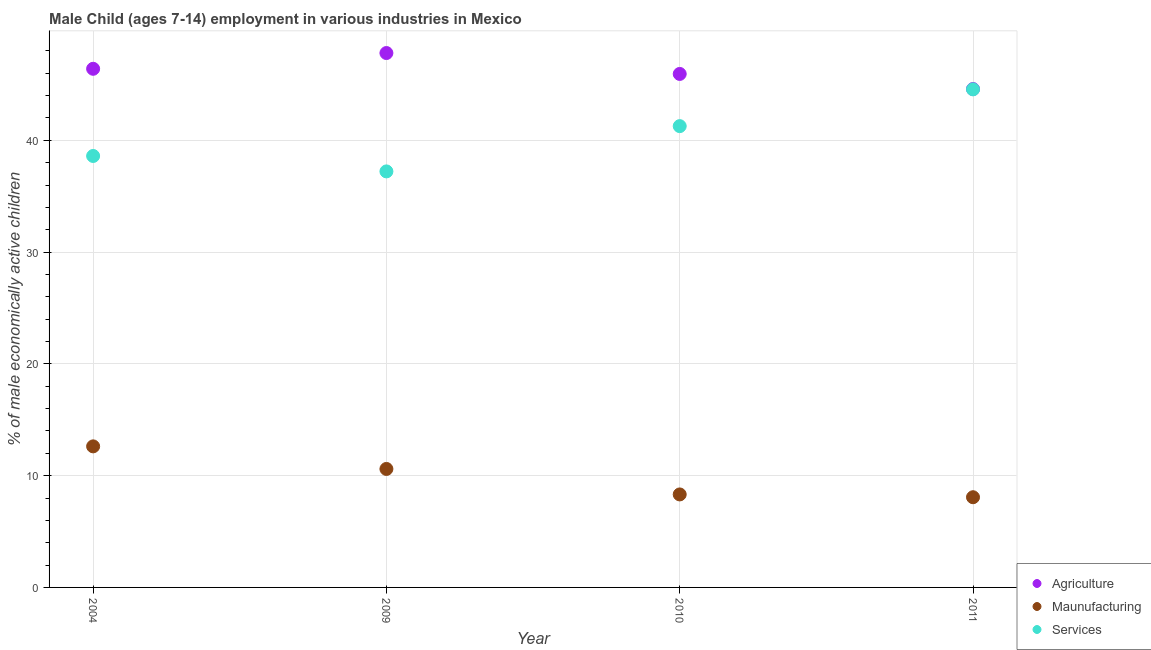How many different coloured dotlines are there?
Give a very brief answer. 3. Is the number of dotlines equal to the number of legend labels?
Ensure brevity in your answer.  Yes. What is the percentage of economically active children in manufacturing in 2009?
Provide a short and direct response. 10.6. Across all years, what is the maximum percentage of economically active children in agriculture?
Offer a very short reply. 47.81. Across all years, what is the minimum percentage of economically active children in manufacturing?
Your answer should be compact. 8.07. In which year was the percentage of economically active children in agriculture maximum?
Offer a terse response. 2009. In which year was the percentage of economically active children in services minimum?
Your answer should be very brief. 2009. What is the total percentage of economically active children in services in the graph?
Provide a succinct answer. 161.65. What is the difference between the percentage of economically active children in services in 2009 and that in 2011?
Provide a short and direct response. -7.34. What is the difference between the percentage of economically active children in services in 2010 and the percentage of economically active children in agriculture in 2004?
Offer a very short reply. -5.13. What is the average percentage of economically active children in services per year?
Give a very brief answer. 40.41. In the year 2009, what is the difference between the percentage of economically active children in services and percentage of economically active children in manufacturing?
Give a very brief answer. 26.62. In how many years, is the percentage of economically active children in manufacturing greater than 34 %?
Provide a short and direct response. 0. What is the ratio of the percentage of economically active children in agriculture in 2010 to that in 2011?
Ensure brevity in your answer.  1.03. Is the percentage of economically active children in agriculture in 2004 less than that in 2010?
Your response must be concise. No. Is the difference between the percentage of economically active children in manufacturing in 2004 and 2009 greater than the difference between the percentage of economically active children in services in 2004 and 2009?
Your response must be concise. Yes. What is the difference between the highest and the second highest percentage of economically active children in manufacturing?
Keep it short and to the point. 2.02. What is the difference between the highest and the lowest percentage of economically active children in manufacturing?
Make the answer very short. 4.55. In how many years, is the percentage of economically active children in services greater than the average percentage of economically active children in services taken over all years?
Ensure brevity in your answer.  2. Is it the case that in every year, the sum of the percentage of economically active children in agriculture and percentage of economically active children in manufacturing is greater than the percentage of economically active children in services?
Keep it short and to the point. Yes. Does the percentage of economically active children in services monotonically increase over the years?
Provide a short and direct response. No. Is the percentage of economically active children in agriculture strictly greater than the percentage of economically active children in manufacturing over the years?
Provide a short and direct response. Yes. Is the percentage of economically active children in services strictly less than the percentage of economically active children in manufacturing over the years?
Ensure brevity in your answer.  No. How many years are there in the graph?
Ensure brevity in your answer.  4. Are the values on the major ticks of Y-axis written in scientific E-notation?
Offer a very short reply. No. Does the graph contain grids?
Provide a short and direct response. Yes. What is the title of the graph?
Keep it short and to the point. Male Child (ages 7-14) employment in various industries in Mexico. Does "Capital account" appear as one of the legend labels in the graph?
Offer a terse response. No. What is the label or title of the Y-axis?
Your answer should be compact. % of male economically active children. What is the % of male economically active children in Agriculture in 2004?
Your response must be concise. 46.4. What is the % of male economically active children in Maunufacturing in 2004?
Keep it short and to the point. 12.62. What is the % of male economically active children in Services in 2004?
Provide a succinct answer. 38.6. What is the % of male economically active children of Agriculture in 2009?
Provide a succinct answer. 47.81. What is the % of male economically active children in Services in 2009?
Provide a short and direct response. 37.22. What is the % of male economically active children of Agriculture in 2010?
Keep it short and to the point. 45.94. What is the % of male economically active children of Maunufacturing in 2010?
Your answer should be compact. 8.32. What is the % of male economically active children of Services in 2010?
Ensure brevity in your answer.  41.27. What is the % of male economically active children of Agriculture in 2011?
Keep it short and to the point. 44.59. What is the % of male economically active children in Maunufacturing in 2011?
Offer a very short reply. 8.07. What is the % of male economically active children in Services in 2011?
Ensure brevity in your answer.  44.56. Across all years, what is the maximum % of male economically active children of Agriculture?
Your response must be concise. 47.81. Across all years, what is the maximum % of male economically active children in Maunufacturing?
Offer a terse response. 12.62. Across all years, what is the maximum % of male economically active children in Services?
Offer a terse response. 44.56. Across all years, what is the minimum % of male economically active children of Agriculture?
Provide a succinct answer. 44.59. Across all years, what is the minimum % of male economically active children in Maunufacturing?
Make the answer very short. 8.07. Across all years, what is the minimum % of male economically active children in Services?
Provide a short and direct response. 37.22. What is the total % of male economically active children in Agriculture in the graph?
Give a very brief answer. 184.74. What is the total % of male economically active children of Maunufacturing in the graph?
Provide a short and direct response. 39.61. What is the total % of male economically active children in Services in the graph?
Your response must be concise. 161.65. What is the difference between the % of male economically active children of Agriculture in 2004 and that in 2009?
Your answer should be compact. -1.41. What is the difference between the % of male economically active children of Maunufacturing in 2004 and that in 2009?
Offer a very short reply. 2.02. What is the difference between the % of male economically active children in Services in 2004 and that in 2009?
Give a very brief answer. 1.38. What is the difference between the % of male economically active children in Agriculture in 2004 and that in 2010?
Your answer should be compact. 0.46. What is the difference between the % of male economically active children of Maunufacturing in 2004 and that in 2010?
Keep it short and to the point. 4.3. What is the difference between the % of male economically active children in Services in 2004 and that in 2010?
Offer a very short reply. -2.67. What is the difference between the % of male economically active children in Agriculture in 2004 and that in 2011?
Keep it short and to the point. 1.81. What is the difference between the % of male economically active children of Maunufacturing in 2004 and that in 2011?
Make the answer very short. 4.55. What is the difference between the % of male economically active children in Services in 2004 and that in 2011?
Provide a short and direct response. -5.96. What is the difference between the % of male economically active children of Agriculture in 2009 and that in 2010?
Offer a very short reply. 1.87. What is the difference between the % of male economically active children in Maunufacturing in 2009 and that in 2010?
Your answer should be very brief. 2.28. What is the difference between the % of male economically active children in Services in 2009 and that in 2010?
Keep it short and to the point. -4.05. What is the difference between the % of male economically active children in Agriculture in 2009 and that in 2011?
Make the answer very short. 3.22. What is the difference between the % of male economically active children of Maunufacturing in 2009 and that in 2011?
Your response must be concise. 2.53. What is the difference between the % of male economically active children of Services in 2009 and that in 2011?
Give a very brief answer. -7.34. What is the difference between the % of male economically active children in Agriculture in 2010 and that in 2011?
Your answer should be compact. 1.35. What is the difference between the % of male economically active children in Maunufacturing in 2010 and that in 2011?
Keep it short and to the point. 0.25. What is the difference between the % of male economically active children of Services in 2010 and that in 2011?
Ensure brevity in your answer.  -3.29. What is the difference between the % of male economically active children of Agriculture in 2004 and the % of male economically active children of Maunufacturing in 2009?
Offer a terse response. 35.8. What is the difference between the % of male economically active children in Agriculture in 2004 and the % of male economically active children in Services in 2009?
Provide a succinct answer. 9.18. What is the difference between the % of male economically active children in Maunufacturing in 2004 and the % of male economically active children in Services in 2009?
Keep it short and to the point. -24.6. What is the difference between the % of male economically active children in Agriculture in 2004 and the % of male economically active children in Maunufacturing in 2010?
Give a very brief answer. 38.08. What is the difference between the % of male economically active children in Agriculture in 2004 and the % of male economically active children in Services in 2010?
Your answer should be compact. 5.13. What is the difference between the % of male economically active children of Maunufacturing in 2004 and the % of male economically active children of Services in 2010?
Offer a terse response. -28.65. What is the difference between the % of male economically active children of Agriculture in 2004 and the % of male economically active children of Maunufacturing in 2011?
Ensure brevity in your answer.  38.33. What is the difference between the % of male economically active children in Agriculture in 2004 and the % of male economically active children in Services in 2011?
Your answer should be compact. 1.84. What is the difference between the % of male economically active children of Maunufacturing in 2004 and the % of male economically active children of Services in 2011?
Provide a succinct answer. -31.94. What is the difference between the % of male economically active children of Agriculture in 2009 and the % of male economically active children of Maunufacturing in 2010?
Your answer should be compact. 39.49. What is the difference between the % of male economically active children in Agriculture in 2009 and the % of male economically active children in Services in 2010?
Give a very brief answer. 6.54. What is the difference between the % of male economically active children of Maunufacturing in 2009 and the % of male economically active children of Services in 2010?
Make the answer very short. -30.67. What is the difference between the % of male economically active children in Agriculture in 2009 and the % of male economically active children in Maunufacturing in 2011?
Ensure brevity in your answer.  39.74. What is the difference between the % of male economically active children of Agriculture in 2009 and the % of male economically active children of Services in 2011?
Offer a terse response. 3.25. What is the difference between the % of male economically active children in Maunufacturing in 2009 and the % of male economically active children in Services in 2011?
Your answer should be very brief. -33.96. What is the difference between the % of male economically active children of Agriculture in 2010 and the % of male economically active children of Maunufacturing in 2011?
Your response must be concise. 37.87. What is the difference between the % of male economically active children of Agriculture in 2010 and the % of male economically active children of Services in 2011?
Offer a terse response. 1.38. What is the difference between the % of male economically active children in Maunufacturing in 2010 and the % of male economically active children in Services in 2011?
Provide a short and direct response. -36.24. What is the average % of male economically active children in Agriculture per year?
Your answer should be compact. 46.19. What is the average % of male economically active children of Maunufacturing per year?
Give a very brief answer. 9.9. What is the average % of male economically active children of Services per year?
Give a very brief answer. 40.41. In the year 2004, what is the difference between the % of male economically active children in Agriculture and % of male economically active children in Maunufacturing?
Offer a terse response. 33.78. In the year 2004, what is the difference between the % of male economically active children of Agriculture and % of male economically active children of Services?
Your answer should be very brief. 7.8. In the year 2004, what is the difference between the % of male economically active children of Maunufacturing and % of male economically active children of Services?
Provide a short and direct response. -25.98. In the year 2009, what is the difference between the % of male economically active children of Agriculture and % of male economically active children of Maunufacturing?
Offer a terse response. 37.21. In the year 2009, what is the difference between the % of male economically active children in Agriculture and % of male economically active children in Services?
Make the answer very short. 10.59. In the year 2009, what is the difference between the % of male economically active children in Maunufacturing and % of male economically active children in Services?
Provide a short and direct response. -26.62. In the year 2010, what is the difference between the % of male economically active children of Agriculture and % of male economically active children of Maunufacturing?
Ensure brevity in your answer.  37.62. In the year 2010, what is the difference between the % of male economically active children in Agriculture and % of male economically active children in Services?
Provide a short and direct response. 4.67. In the year 2010, what is the difference between the % of male economically active children of Maunufacturing and % of male economically active children of Services?
Keep it short and to the point. -32.95. In the year 2011, what is the difference between the % of male economically active children of Agriculture and % of male economically active children of Maunufacturing?
Provide a succinct answer. 36.52. In the year 2011, what is the difference between the % of male economically active children in Maunufacturing and % of male economically active children in Services?
Your answer should be very brief. -36.49. What is the ratio of the % of male economically active children of Agriculture in 2004 to that in 2009?
Give a very brief answer. 0.97. What is the ratio of the % of male economically active children in Maunufacturing in 2004 to that in 2009?
Keep it short and to the point. 1.19. What is the ratio of the % of male economically active children of Services in 2004 to that in 2009?
Your answer should be compact. 1.04. What is the ratio of the % of male economically active children of Maunufacturing in 2004 to that in 2010?
Ensure brevity in your answer.  1.52. What is the ratio of the % of male economically active children of Services in 2004 to that in 2010?
Your answer should be very brief. 0.94. What is the ratio of the % of male economically active children of Agriculture in 2004 to that in 2011?
Provide a succinct answer. 1.04. What is the ratio of the % of male economically active children of Maunufacturing in 2004 to that in 2011?
Keep it short and to the point. 1.56. What is the ratio of the % of male economically active children in Services in 2004 to that in 2011?
Your response must be concise. 0.87. What is the ratio of the % of male economically active children in Agriculture in 2009 to that in 2010?
Ensure brevity in your answer.  1.04. What is the ratio of the % of male economically active children of Maunufacturing in 2009 to that in 2010?
Keep it short and to the point. 1.27. What is the ratio of the % of male economically active children in Services in 2009 to that in 2010?
Ensure brevity in your answer.  0.9. What is the ratio of the % of male economically active children in Agriculture in 2009 to that in 2011?
Give a very brief answer. 1.07. What is the ratio of the % of male economically active children in Maunufacturing in 2009 to that in 2011?
Offer a very short reply. 1.31. What is the ratio of the % of male economically active children of Services in 2009 to that in 2011?
Ensure brevity in your answer.  0.84. What is the ratio of the % of male economically active children in Agriculture in 2010 to that in 2011?
Keep it short and to the point. 1.03. What is the ratio of the % of male economically active children of Maunufacturing in 2010 to that in 2011?
Ensure brevity in your answer.  1.03. What is the ratio of the % of male economically active children in Services in 2010 to that in 2011?
Offer a very short reply. 0.93. What is the difference between the highest and the second highest % of male economically active children in Agriculture?
Keep it short and to the point. 1.41. What is the difference between the highest and the second highest % of male economically active children of Maunufacturing?
Provide a short and direct response. 2.02. What is the difference between the highest and the second highest % of male economically active children in Services?
Offer a very short reply. 3.29. What is the difference between the highest and the lowest % of male economically active children in Agriculture?
Make the answer very short. 3.22. What is the difference between the highest and the lowest % of male economically active children in Maunufacturing?
Your answer should be compact. 4.55. What is the difference between the highest and the lowest % of male economically active children of Services?
Your answer should be compact. 7.34. 